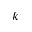<formula> <loc_0><loc_0><loc_500><loc_500>k</formula> 